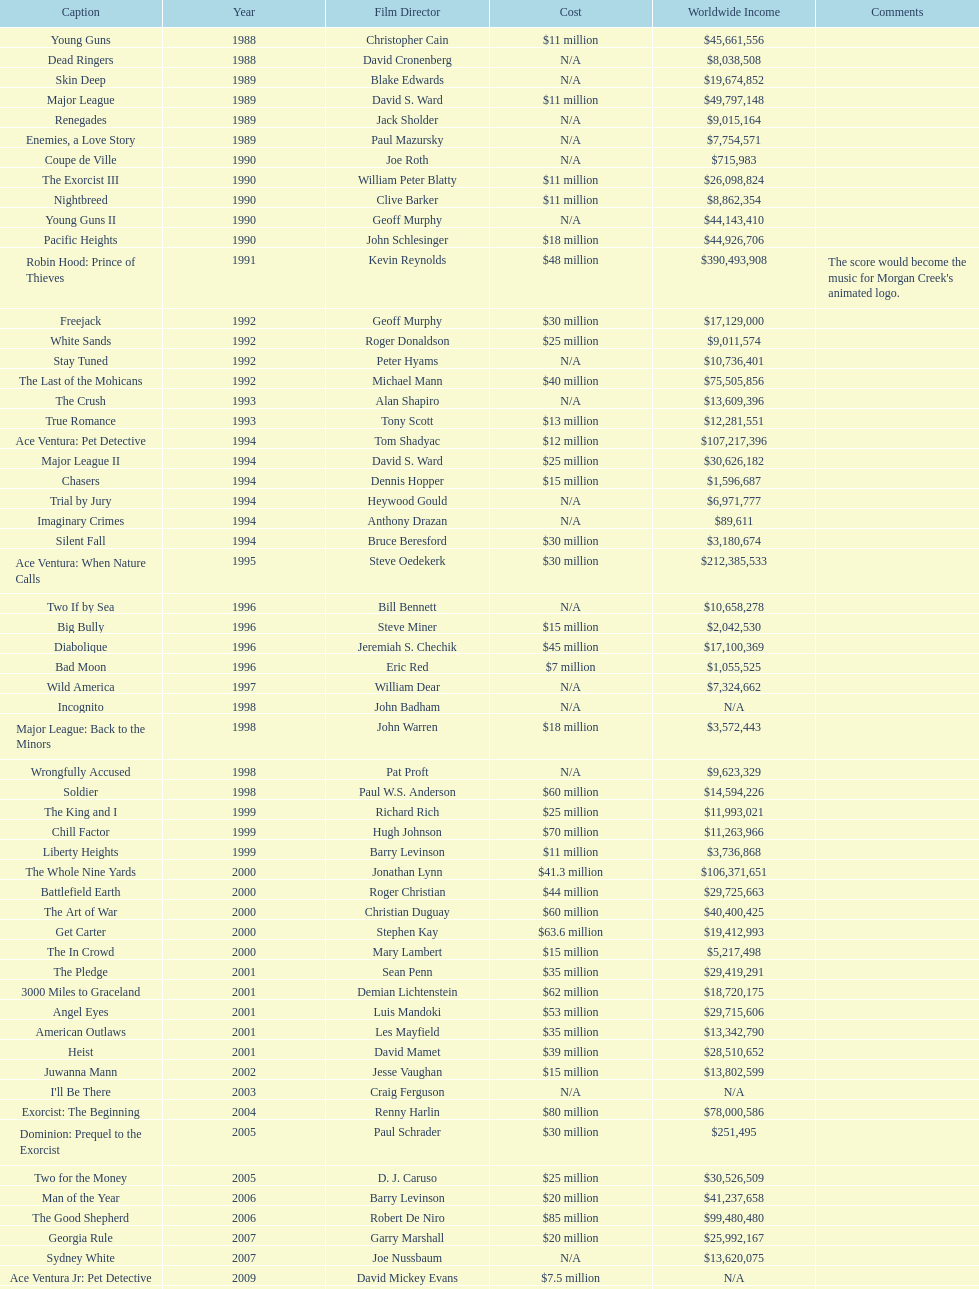After young guns, what was the next movie with the exact same budget? Major League. 